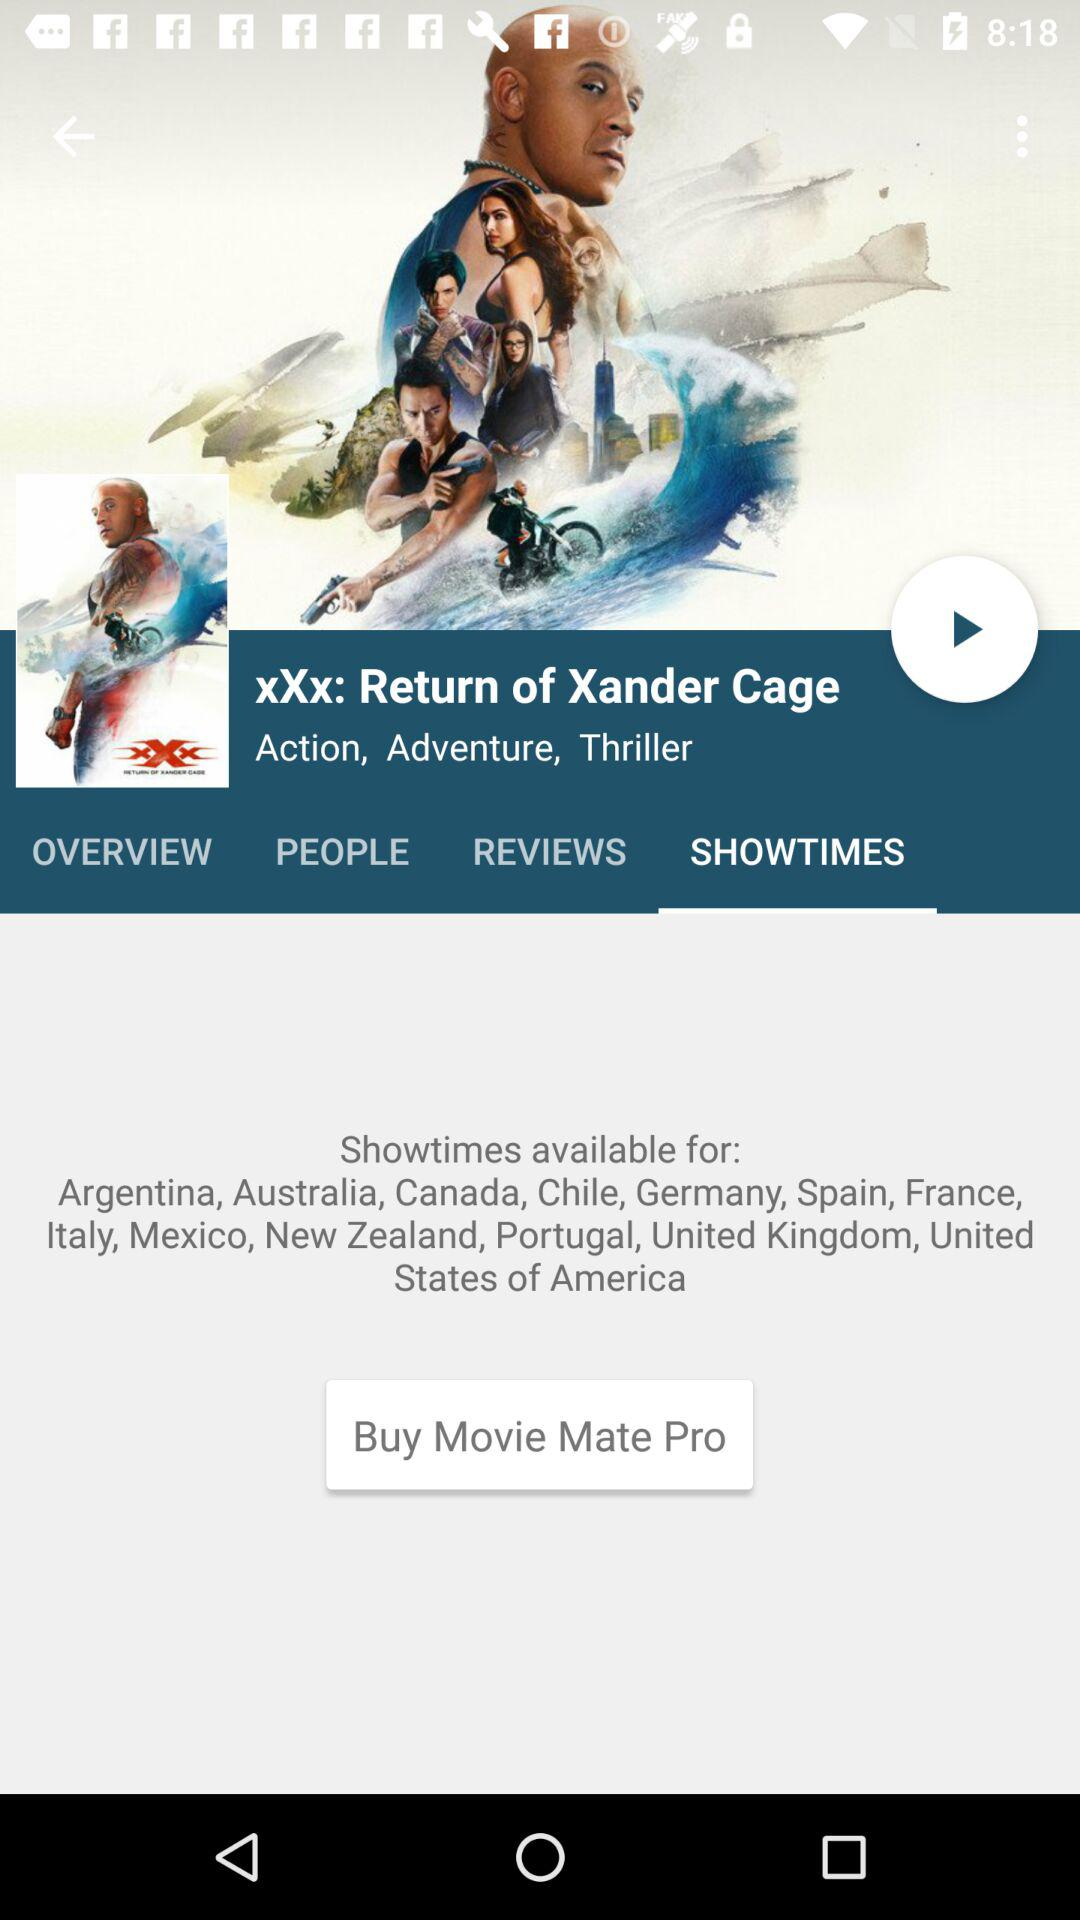Which parental guidance rating did "XXX: Return of Xander Cage" receive?
When the provided information is insufficient, respond with <no answer>. <no answer> 